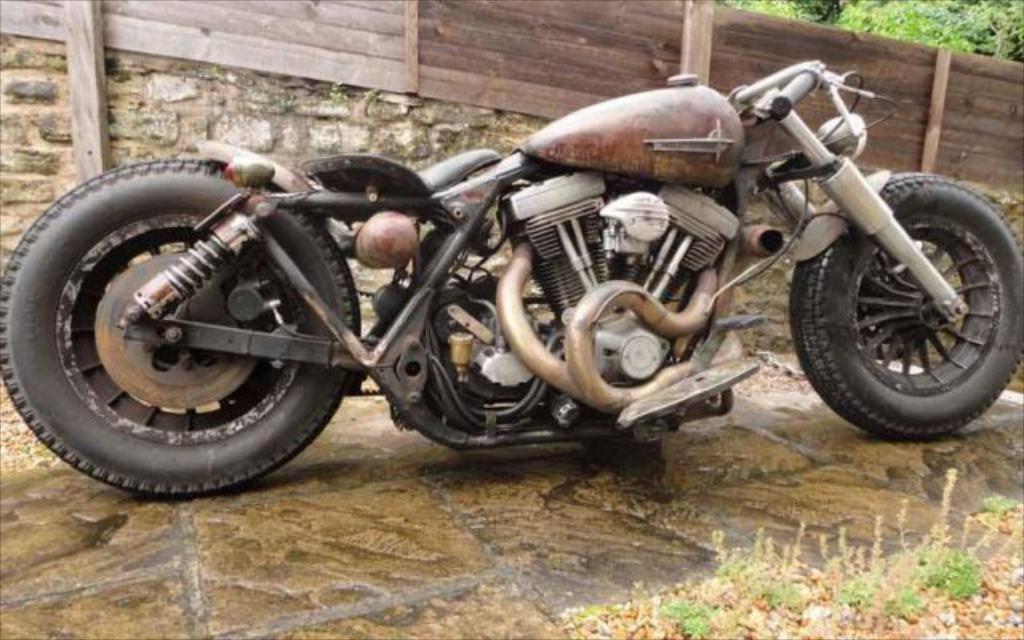In one or two sentences, can you explain what this image depicts? In the center of the image there is a bike. In the background we can see a fence and trees. 